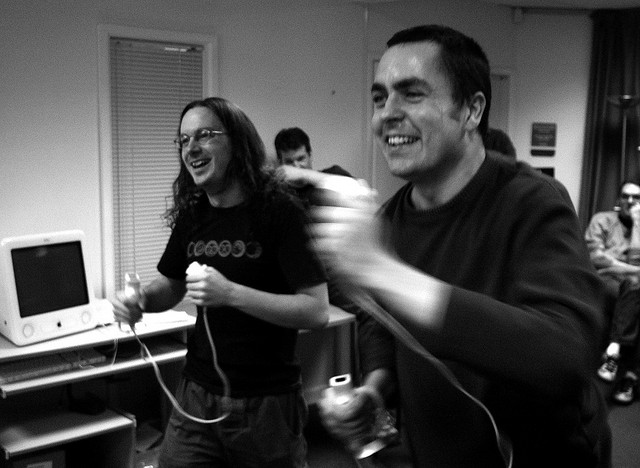<image>What event is this? It is ambiguous what event this is. It could be a gaming event or a party. What event is this? I am not sure what event this is. It can be seen as a gaming event, a wii party, or a birthday party. 